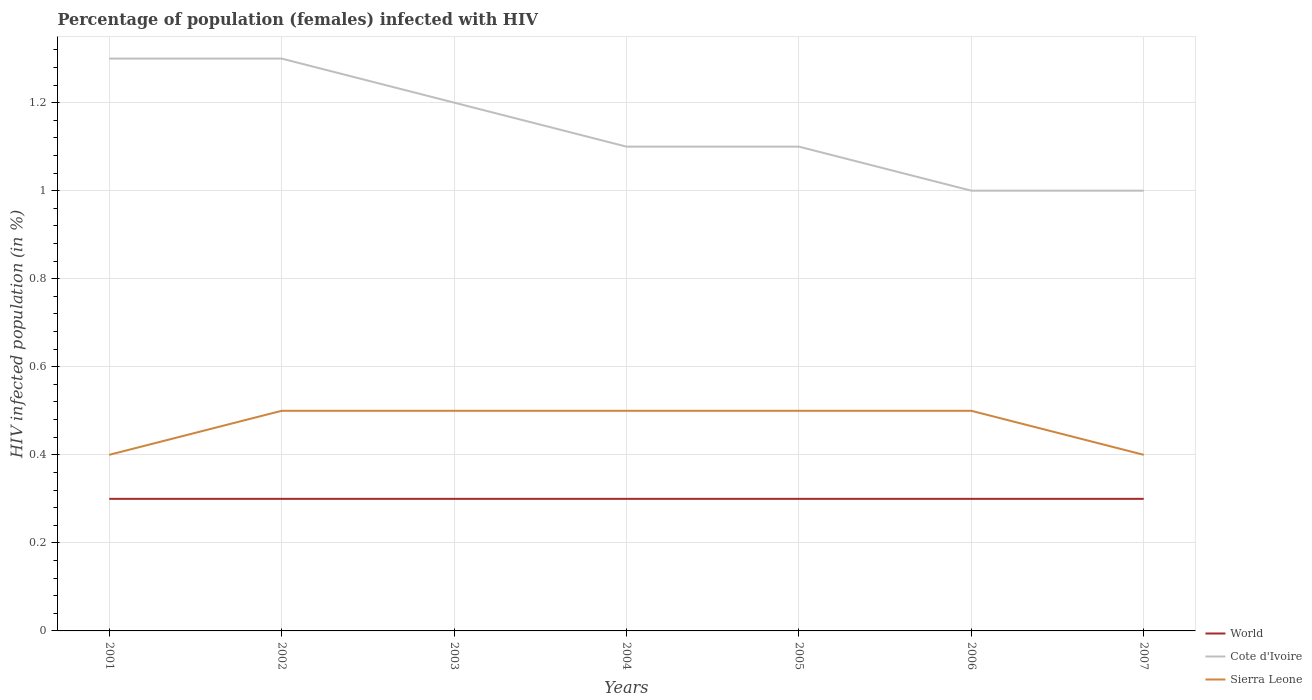Does the line corresponding to World intersect with the line corresponding to Sierra Leone?
Make the answer very short. No. What is the difference between the highest and the second highest percentage of HIV infected female population in Cote d'Ivoire?
Ensure brevity in your answer.  0.3. What is the difference between the highest and the lowest percentage of HIV infected female population in World?
Keep it short and to the point. 0. How many lines are there?
Your response must be concise. 3. How many years are there in the graph?
Your answer should be compact. 7. What is the difference between two consecutive major ticks on the Y-axis?
Offer a very short reply. 0.2. Are the values on the major ticks of Y-axis written in scientific E-notation?
Offer a very short reply. No. Where does the legend appear in the graph?
Offer a very short reply. Bottom right. How many legend labels are there?
Give a very brief answer. 3. How are the legend labels stacked?
Keep it short and to the point. Vertical. What is the title of the graph?
Provide a succinct answer. Percentage of population (females) infected with HIV. Does "Curacao" appear as one of the legend labels in the graph?
Keep it short and to the point. No. What is the label or title of the X-axis?
Your answer should be very brief. Years. What is the label or title of the Y-axis?
Offer a very short reply. HIV infected population (in %). What is the HIV infected population (in %) of Cote d'Ivoire in 2001?
Offer a terse response. 1.3. What is the HIV infected population (in %) in Cote d'Ivoire in 2002?
Your answer should be very brief. 1.3. What is the HIV infected population (in %) of World in 2003?
Make the answer very short. 0.3. What is the HIV infected population (in %) in Cote d'Ivoire in 2004?
Provide a succinct answer. 1.1. What is the HIV infected population (in %) of World in 2005?
Keep it short and to the point. 0.3. What is the HIV infected population (in %) in Cote d'Ivoire in 2005?
Offer a very short reply. 1.1. What is the HIV infected population (in %) in Sierra Leone in 2005?
Ensure brevity in your answer.  0.5. What is the HIV infected population (in %) in Cote d'Ivoire in 2007?
Provide a short and direct response. 1. Across all years, what is the maximum HIV infected population (in %) of Sierra Leone?
Your response must be concise. 0.5. Across all years, what is the minimum HIV infected population (in %) in Sierra Leone?
Provide a short and direct response. 0.4. What is the total HIV infected population (in %) in Sierra Leone in the graph?
Offer a terse response. 3.3. What is the difference between the HIV infected population (in %) in Sierra Leone in 2001 and that in 2002?
Your response must be concise. -0.1. What is the difference between the HIV infected population (in %) of Cote d'Ivoire in 2001 and that in 2003?
Keep it short and to the point. 0.1. What is the difference between the HIV infected population (in %) in World in 2001 and that in 2004?
Give a very brief answer. 0. What is the difference between the HIV infected population (in %) in Cote d'Ivoire in 2001 and that in 2004?
Provide a short and direct response. 0.2. What is the difference between the HIV infected population (in %) in Sierra Leone in 2001 and that in 2005?
Your answer should be compact. -0.1. What is the difference between the HIV infected population (in %) in World in 2001 and that in 2006?
Keep it short and to the point. 0. What is the difference between the HIV infected population (in %) of Cote d'Ivoire in 2001 and that in 2006?
Ensure brevity in your answer.  0.3. What is the difference between the HIV infected population (in %) of Sierra Leone in 2001 and that in 2006?
Make the answer very short. -0.1. What is the difference between the HIV infected population (in %) of World in 2002 and that in 2003?
Provide a succinct answer. 0. What is the difference between the HIV infected population (in %) of Cote d'Ivoire in 2002 and that in 2003?
Offer a very short reply. 0.1. What is the difference between the HIV infected population (in %) of World in 2002 and that in 2004?
Make the answer very short. 0. What is the difference between the HIV infected population (in %) in Cote d'Ivoire in 2002 and that in 2004?
Offer a terse response. 0.2. What is the difference between the HIV infected population (in %) in Cote d'Ivoire in 2002 and that in 2005?
Offer a terse response. 0.2. What is the difference between the HIV infected population (in %) in World in 2002 and that in 2006?
Keep it short and to the point. 0. What is the difference between the HIV infected population (in %) of Cote d'Ivoire in 2002 and that in 2006?
Offer a terse response. 0.3. What is the difference between the HIV infected population (in %) of Sierra Leone in 2002 and that in 2006?
Your response must be concise. 0. What is the difference between the HIV infected population (in %) in Sierra Leone in 2002 and that in 2007?
Your answer should be compact. 0.1. What is the difference between the HIV infected population (in %) in World in 2003 and that in 2004?
Give a very brief answer. 0. What is the difference between the HIV infected population (in %) in Sierra Leone in 2003 and that in 2004?
Provide a short and direct response. 0. What is the difference between the HIV infected population (in %) of World in 2003 and that in 2005?
Offer a very short reply. 0. What is the difference between the HIV infected population (in %) in Sierra Leone in 2003 and that in 2005?
Provide a short and direct response. 0. What is the difference between the HIV infected population (in %) in Cote d'Ivoire in 2003 and that in 2006?
Your answer should be compact. 0.2. What is the difference between the HIV infected population (in %) in World in 2003 and that in 2007?
Offer a terse response. 0. What is the difference between the HIV infected population (in %) in Cote d'Ivoire in 2003 and that in 2007?
Keep it short and to the point. 0.2. What is the difference between the HIV infected population (in %) of Sierra Leone in 2003 and that in 2007?
Offer a very short reply. 0.1. What is the difference between the HIV infected population (in %) in Cote d'Ivoire in 2004 and that in 2005?
Offer a very short reply. 0. What is the difference between the HIV infected population (in %) of Cote d'Ivoire in 2004 and that in 2006?
Provide a succinct answer. 0.1. What is the difference between the HIV infected population (in %) of Sierra Leone in 2004 and that in 2006?
Make the answer very short. 0. What is the difference between the HIV infected population (in %) of Cote d'Ivoire in 2004 and that in 2007?
Keep it short and to the point. 0.1. What is the difference between the HIV infected population (in %) of Cote d'Ivoire in 2005 and that in 2006?
Provide a short and direct response. 0.1. What is the difference between the HIV infected population (in %) in World in 2005 and that in 2007?
Give a very brief answer. 0. What is the difference between the HIV infected population (in %) in Cote d'Ivoire in 2005 and that in 2007?
Make the answer very short. 0.1. What is the difference between the HIV infected population (in %) of Sierra Leone in 2005 and that in 2007?
Provide a succinct answer. 0.1. What is the difference between the HIV infected population (in %) in World in 2006 and that in 2007?
Offer a very short reply. 0. What is the difference between the HIV infected population (in %) in Cote d'Ivoire in 2006 and that in 2007?
Your response must be concise. 0. What is the difference between the HIV infected population (in %) of World in 2001 and the HIV infected population (in %) of Cote d'Ivoire in 2003?
Give a very brief answer. -0.9. What is the difference between the HIV infected population (in %) of Cote d'Ivoire in 2001 and the HIV infected population (in %) of Sierra Leone in 2004?
Keep it short and to the point. 0.8. What is the difference between the HIV infected population (in %) of World in 2001 and the HIV infected population (in %) of Cote d'Ivoire in 2005?
Your answer should be very brief. -0.8. What is the difference between the HIV infected population (in %) in World in 2001 and the HIV infected population (in %) in Sierra Leone in 2005?
Offer a very short reply. -0.2. What is the difference between the HIV infected population (in %) in Cote d'Ivoire in 2001 and the HIV infected population (in %) in Sierra Leone in 2005?
Give a very brief answer. 0.8. What is the difference between the HIV infected population (in %) of World in 2001 and the HIV infected population (in %) of Cote d'Ivoire in 2006?
Give a very brief answer. -0.7. What is the difference between the HIV infected population (in %) in World in 2001 and the HIV infected population (in %) in Sierra Leone in 2006?
Offer a very short reply. -0.2. What is the difference between the HIV infected population (in %) in Cote d'Ivoire in 2001 and the HIV infected population (in %) in Sierra Leone in 2006?
Your answer should be very brief. 0.8. What is the difference between the HIV infected population (in %) in World in 2001 and the HIV infected population (in %) in Cote d'Ivoire in 2007?
Offer a terse response. -0.7. What is the difference between the HIV infected population (in %) of World in 2002 and the HIV infected population (in %) of Cote d'Ivoire in 2003?
Make the answer very short. -0.9. What is the difference between the HIV infected population (in %) in Cote d'Ivoire in 2002 and the HIV infected population (in %) in Sierra Leone in 2003?
Your answer should be very brief. 0.8. What is the difference between the HIV infected population (in %) of World in 2002 and the HIV infected population (in %) of Sierra Leone in 2004?
Your response must be concise. -0.2. What is the difference between the HIV infected population (in %) of World in 2002 and the HIV infected population (in %) of Sierra Leone in 2005?
Keep it short and to the point. -0.2. What is the difference between the HIV infected population (in %) in Cote d'Ivoire in 2002 and the HIV infected population (in %) in Sierra Leone in 2005?
Provide a succinct answer. 0.8. What is the difference between the HIV infected population (in %) in World in 2002 and the HIV infected population (in %) in Cote d'Ivoire in 2006?
Ensure brevity in your answer.  -0.7. What is the difference between the HIV infected population (in %) of World in 2002 and the HIV infected population (in %) of Sierra Leone in 2006?
Make the answer very short. -0.2. What is the difference between the HIV infected population (in %) of Cote d'Ivoire in 2002 and the HIV infected population (in %) of Sierra Leone in 2006?
Provide a short and direct response. 0.8. What is the difference between the HIV infected population (in %) in World in 2002 and the HIV infected population (in %) in Cote d'Ivoire in 2007?
Provide a succinct answer. -0.7. What is the difference between the HIV infected population (in %) of World in 2002 and the HIV infected population (in %) of Sierra Leone in 2007?
Your answer should be very brief. -0.1. What is the difference between the HIV infected population (in %) in Cote d'Ivoire in 2002 and the HIV infected population (in %) in Sierra Leone in 2007?
Your answer should be compact. 0.9. What is the difference between the HIV infected population (in %) of World in 2003 and the HIV infected population (in %) of Cote d'Ivoire in 2004?
Offer a terse response. -0.8. What is the difference between the HIV infected population (in %) of Cote d'Ivoire in 2003 and the HIV infected population (in %) of Sierra Leone in 2004?
Provide a short and direct response. 0.7. What is the difference between the HIV infected population (in %) of World in 2003 and the HIV infected population (in %) of Cote d'Ivoire in 2005?
Offer a terse response. -0.8. What is the difference between the HIV infected population (in %) in World in 2003 and the HIV infected population (in %) in Cote d'Ivoire in 2006?
Your answer should be compact. -0.7. What is the difference between the HIV infected population (in %) of World in 2003 and the HIV infected population (in %) of Cote d'Ivoire in 2007?
Provide a short and direct response. -0.7. What is the difference between the HIV infected population (in %) in World in 2004 and the HIV infected population (in %) in Sierra Leone in 2005?
Offer a terse response. -0.2. What is the difference between the HIV infected population (in %) of Cote d'Ivoire in 2004 and the HIV infected population (in %) of Sierra Leone in 2005?
Offer a terse response. 0.6. What is the difference between the HIV infected population (in %) of World in 2004 and the HIV infected population (in %) of Cote d'Ivoire in 2006?
Your answer should be compact. -0.7. What is the difference between the HIV infected population (in %) of World in 2004 and the HIV infected population (in %) of Sierra Leone in 2006?
Ensure brevity in your answer.  -0.2. What is the difference between the HIV infected population (in %) of World in 2004 and the HIV infected population (in %) of Cote d'Ivoire in 2007?
Offer a terse response. -0.7. What is the difference between the HIV infected population (in %) of Cote d'Ivoire in 2004 and the HIV infected population (in %) of Sierra Leone in 2007?
Offer a terse response. 0.7. What is the difference between the HIV infected population (in %) of Cote d'Ivoire in 2005 and the HIV infected population (in %) of Sierra Leone in 2006?
Offer a very short reply. 0.6. What is the difference between the HIV infected population (in %) of World in 2005 and the HIV infected population (in %) of Sierra Leone in 2007?
Your answer should be very brief. -0.1. What is the difference between the HIV infected population (in %) of Cote d'Ivoire in 2005 and the HIV infected population (in %) of Sierra Leone in 2007?
Give a very brief answer. 0.7. What is the difference between the HIV infected population (in %) in World in 2006 and the HIV infected population (in %) in Sierra Leone in 2007?
Provide a short and direct response. -0.1. What is the average HIV infected population (in %) in World per year?
Keep it short and to the point. 0.3. What is the average HIV infected population (in %) in Cote d'Ivoire per year?
Your answer should be very brief. 1.14. What is the average HIV infected population (in %) in Sierra Leone per year?
Your answer should be compact. 0.47. In the year 2001, what is the difference between the HIV infected population (in %) of World and HIV infected population (in %) of Cote d'Ivoire?
Offer a very short reply. -1. In the year 2001, what is the difference between the HIV infected population (in %) of World and HIV infected population (in %) of Sierra Leone?
Your answer should be very brief. -0.1. In the year 2001, what is the difference between the HIV infected population (in %) of Cote d'Ivoire and HIV infected population (in %) of Sierra Leone?
Your answer should be very brief. 0.9. In the year 2003, what is the difference between the HIV infected population (in %) of World and HIV infected population (in %) of Sierra Leone?
Make the answer very short. -0.2. In the year 2003, what is the difference between the HIV infected population (in %) of Cote d'Ivoire and HIV infected population (in %) of Sierra Leone?
Give a very brief answer. 0.7. In the year 2004, what is the difference between the HIV infected population (in %) in World and HIV infected population (in %) in Sierra Leone?
Give a very brief answer. -0.2. In the year 2005, what is the difference between the HIV infected population (in %) in World and HIV infected population (in %) in Cote d'Ivoire?
Offer a terse response. -0.8. In the year 2005, what is the difference between the HIV infected population (in %) in Cote d'Ivoire and HIV infected population (in %) in Sierra Leone?
Provide a succinct answer. 0.6. What is the ratio of the HIV infected population (in %) in World in 2001 to that in 2002?
Your response must be concise. 1. What is the ratio of the HIV infected population (in %) of Sierra Leone in 2001 to that in 2003?
Your answer should be very brief. 0.8. What is the ratio of the HIV infected population (in %) of World in 2001 to that in 2004?
Offer a terse response. 1. What is the ratio of the HIV infected population (in %) in Cote d'Ivoire in 2001 to that in 2004?
Your answer should be compact. 1.18. What is the ratio of the HIV infected population (in %) of Cote d'Ivoire in 2001 to that in 2005?
Your response must be concise. 1.18. What is the ratio of the HIV infected population (in %) of Sierra Leone in 2001 to that in 2005?
Offer a terse response. 0.8. What is the ratio of the HIV infected population (in %) in World in 2001 to that in 2007?
Provide a succinct answer. 1. What is the ratio of the HIV infected population (in %) of Cote d'Ivoire in 2001 to that in 2007?
Ensure brevity in your answer.  1.3. What is the ratio of the HIV infected population (in %) in Sierra Leone in 2001 to that in 2007?
Make the answer very short. 1. What is the ratio of the HIV infected population (in %) of Cote d'Ivoire in 2002 to that in 2004?
Make the answer very short. 1.18. What is the ratio of the HIV infected population (in %) in World in 2002 to that in 2005?
Make the answer very short. 1. What is the ratio of the HIV infected population (in %) of Cote d'Ivoire in 2002 to that in 2005?
Provide a short and direct response. 1.18. What is the ratio of the HIV infected population (in %) in World in 2002 to that in 2006?
Offer a terse response. 1. What is the ratio of the HIV infected population (in %) in Cote d'Ivoire in 2002 to that in 2006?
Your answer should be very brief. 1.3. What is the ratio of the HIV infected population (in %) of Sierra Leone in 2002 to that in 2006?
Offer a very short reply. 1. What is the ratio of the HIV infected population (in %) of World in 2002 to that in 2007?
Offer a terse response. 1. What is the ratio of the HIV infected population (in %) of Cote d'Ivoire in 2002 to that in 2007?
Ensure brevity in your answer.  1.3. What is the ratio of the HIV infected population (in %) in Sierra Leone in 2002 to that in 2007?
Provide a short and direct response. 1.25. What is the ratio of the HIV infected population (in %) of World in 2003 to that in 2004?
Provide a short and direct response. 1. What is the ratio of the HIV infected population (in %) of Sierra Leone in 2003 to that in 2004?
Provide a short and direct response. 1. What is the ratio of the HIV infected population (in %) of World in 2003 to that in 2005?
Give a very brief answer. 1. What is the ratio of the HIV infected population (in %) in Sierra Leone in 2003 to that in 2005?
Your answer should be very brief. 1. What is the ratio of the HIV infected population (in %) in Sierra Leone in 2003 to that in 2006?
Offer a very short reply. 1. What is the ratio of the HIV infected population (in %) in Cote d'Ivoire in 2003 to that in 2007?
Offer a very short reply. 1.2. What is the ratio of the HIV infected population (in %) of Cote d'Ivoire in 2004 to that in 2006?
Give a very brief answer. 1.1. What is the ratio of the HIV infected population (in %) in Sierra Leone in 2004 to that in 2006?
Your answer should be very brief. 1. What is the ratio of the HIV infected population (in %) in Sierra Leone in 2004 to that in 2007?
Your answer should be very brief. 1.25. What is the ratio of the HIV infected population (in %) of Sierra Leone in 2005 to that in 2006?
Your response must be concise. 1. What is the ratio of the HIV infected population (in %) of World in 2005 to that in 2007?
Offer a terse response. 1. What is the ratio of the HIV infected population (in %) in Cote d'Ivoire in 2005 to that in 2007?
Keep it short and to the point. 1.1. What is the ratio of the HIV infected population (in %) of Sierra Leone in 2005 to that in 2007?
Your answer should be very brief. 1.25. What is the ratio of the HIV infected population (in %) in World in 2006 to that in 2007?
Provide a succinct answer. 1. What is the ratio of the HIV infected population (in %) in Sierra Leone in 2006 to that in 2007?
Keep it short and to the point. 1.25. What is the difference between the highest and the second highest HIV infected population (in %) of Cote d'Ivoire?
Give a very brief answer. 0. What is the difference between the highest and the lowest HIV infected population (in %) of World?
Ensure brevity in your answer.  0. What is the difference between the highest and the lowest HIV infected population (in %) in Cote d'Ivoire?
Offer a terse response. 0.3. What is the difference between the highest and the lowest HIV infected population (in %) of Sierra Leone?
Your response must be concise. 0.1. 